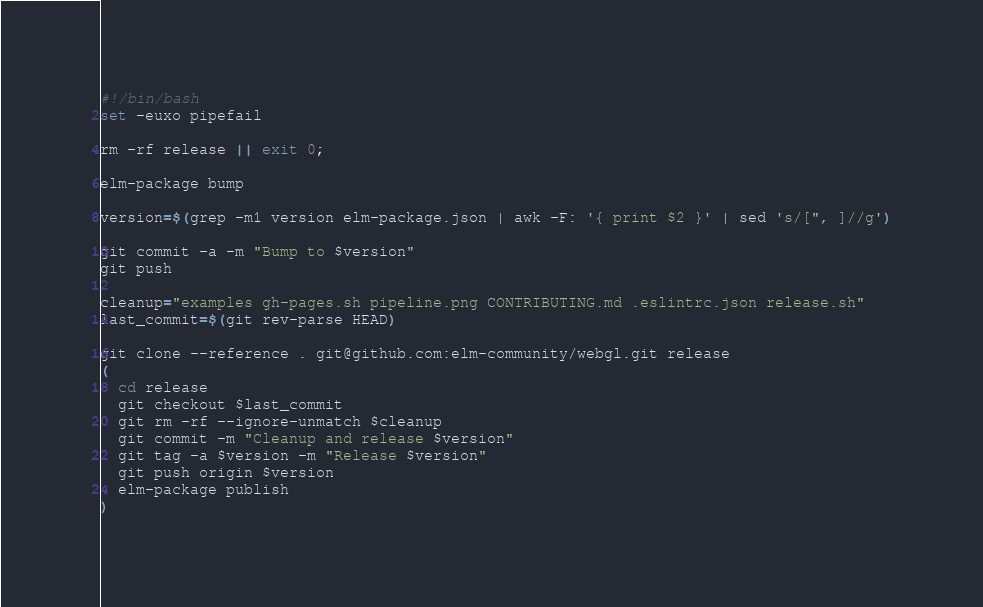<code> <loc_0><loc_0><loc_500><loc_500><_Bash_>#!/bin/bash
set -euxo pipefail

rm -rf release || exit 0;

elm-package bump

version=$(grep -m1 version elm-package.json | awk -F: '{ print $2 }' | sed 's/[", ]//g')

git commit -a -m "Bump to $version"
git push

cleanup="examples gh-pages.sh pipeline.png CONTRIBUTING.md .eslintrc.json release.sh"
last_commit=$(git rev-parse HEAD)

git clone --reference . git@github.com:elm-community/webgl.git release
(
  cd release
  git checkout $last_commit
  git rm -rf --ignore-unmatch $cleanup
  git commit -m "Cleanup and release $version"
  git tag -a $version -m "Release $version"
  git push origin $version
  elm-package publish
)
</code> 